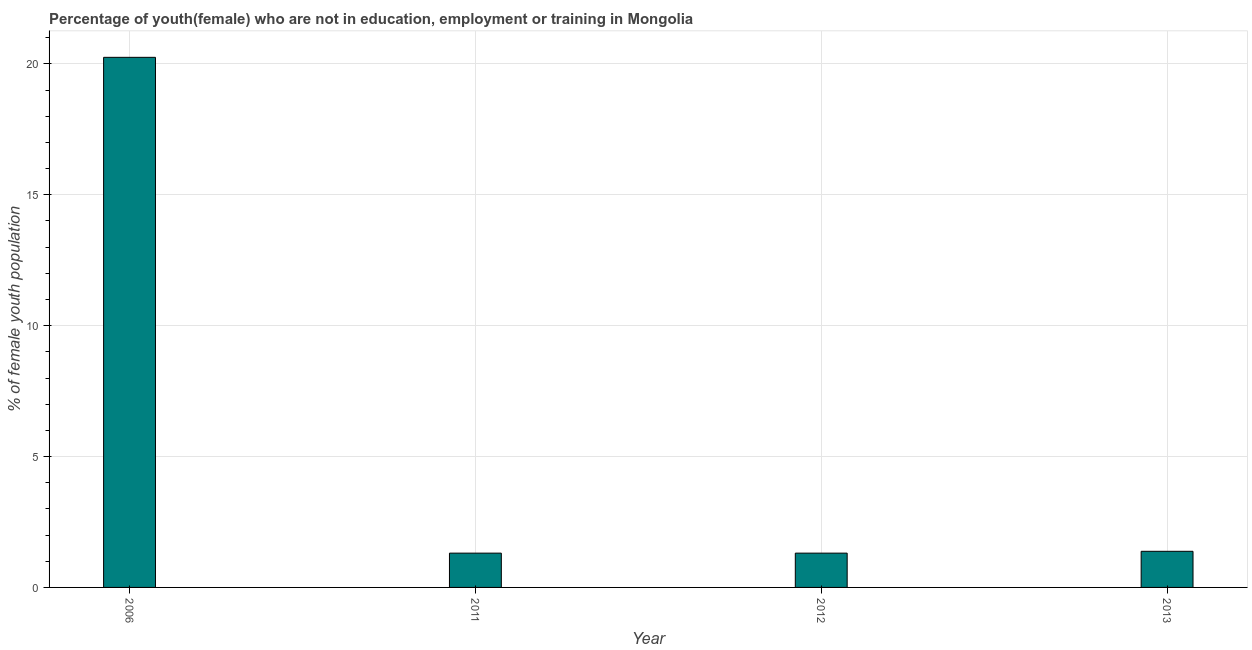Does the graph contain any zero values?
Provide a short and direct response. No. What is the title of the graph?
Provide a succinct answer. Percentage of youth(female) who are not in education, employment or training in Mongolia. What is the label or title of the X-axis?
Offer a very short reply. Year. What is the label or title of the Y-axis?
Give a very brief answer. % of female youth population. What is the unemployed female youth population in 2012?
Offer a very short reply. 1.31. Across all years, what is the maximum unemployed female youth population?
Your answer should be very brief. 20.25. Across all years, what is the minimum unemployed female youth population?
Ensure brevity in your answer.  1.31. In which year was the unemployed female youth population minimum?
Ensure brevity in your answer.  2011. What is the sum of the unemployed female youth population?
Provide a succinct answer. 24.25. What is the difference between the unemployed female youth population in 2006 and 2012?
Offer a very short reply. 18.94. What is the average unemployed female youth population per year?
Your answer should be very brief. 6.06. What is the median unemployed female youth population?
Your answer should be compact. 1.34. In how many years, is the unemployed female youth population greater than 14 %?
Your answer should be very brief. 1. Is the unemployed female youth population in 2006 less than that in 2012?
Your answer should be compact. No. What is the difference between the highest and the second highest unemployed female youth population?
Your answer should be very brief. 18.87. Is the sum of the unemployed female youth population in 2006 and 2012 greater than the maximum unemployed female youth population across all years?
Provide a succinct answer. Yes. What is the difference between the highest and the lowest unemployed female youth population?
Make the answer very short. 18.94. In how many years, is the unemployed female youth population greater than the average unemployed female youth population taken over all years?
Make the answer very short. 1. How many bars are there?
Your answer should be very brief. 4. How many years are there in the graph?
Provide a short and direct response. 4. Are the values on the major ticks of Y-axis written in scientific E-notation?
Keep it short and to the point. No. What is the % of female youth population in 2006?
Ensure brevity in your answer.  20.25. What is the % of female youth population in 2011?
Give a very brief answer. 1.31. What is the % of female youth population of 2012?
Make the answer very short. 1.31. What is the % of female youth population of 2013?
Offer a very short reply. 1.38. What is the difference between the % of female youth population in 2006 and 2011?
Give a very brief answer. 18.94. What is the difference between the % of female youth population in 2006 and 2012?
Provide a succinct answer. 18.94. What is the difference between the % of female youth population in 2006 and 2013?
Your response must be concise. 18.87. What is the difference between the % of female youth population in 2011 and 2013?
Your answer should be compact. -0.07. What is the difference between the % of female youth population in 2012 and 2013?
Keep it short and to the point. -0.07. What is the ratio of the % of female youth population in 2006 to that in 2011?
Your response must be concise. 15.46. What is the ratio of the % of female youth population in 2006 to that in 2012?
Provide a succinct answer. 15.46. What is the ratio of the % of female youth population in 2006 to that in 2013?
Ensure brevity in your answer.  14.67. What is the ratio of the % of female youth population in 2011 to that in 2012?
Offer a terse response. 1. What is the ratio of the % of female youth population in 2011 to that in 2013?
Ensure brevity in your answer.  0.95. What is the ratio of the % of female youth population in 2012 to that in 2013?
Your answer should be very brief. 0.95. 